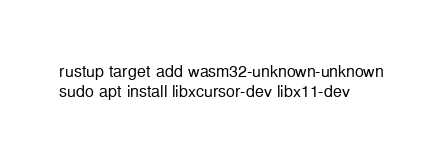<code> <loc_0><loc_0><loc_500><loc_500><_Bash_>rustup target add wasm32-unknown-unknown
sudo apt install libxcursor-dev libx11-dev

</code> 